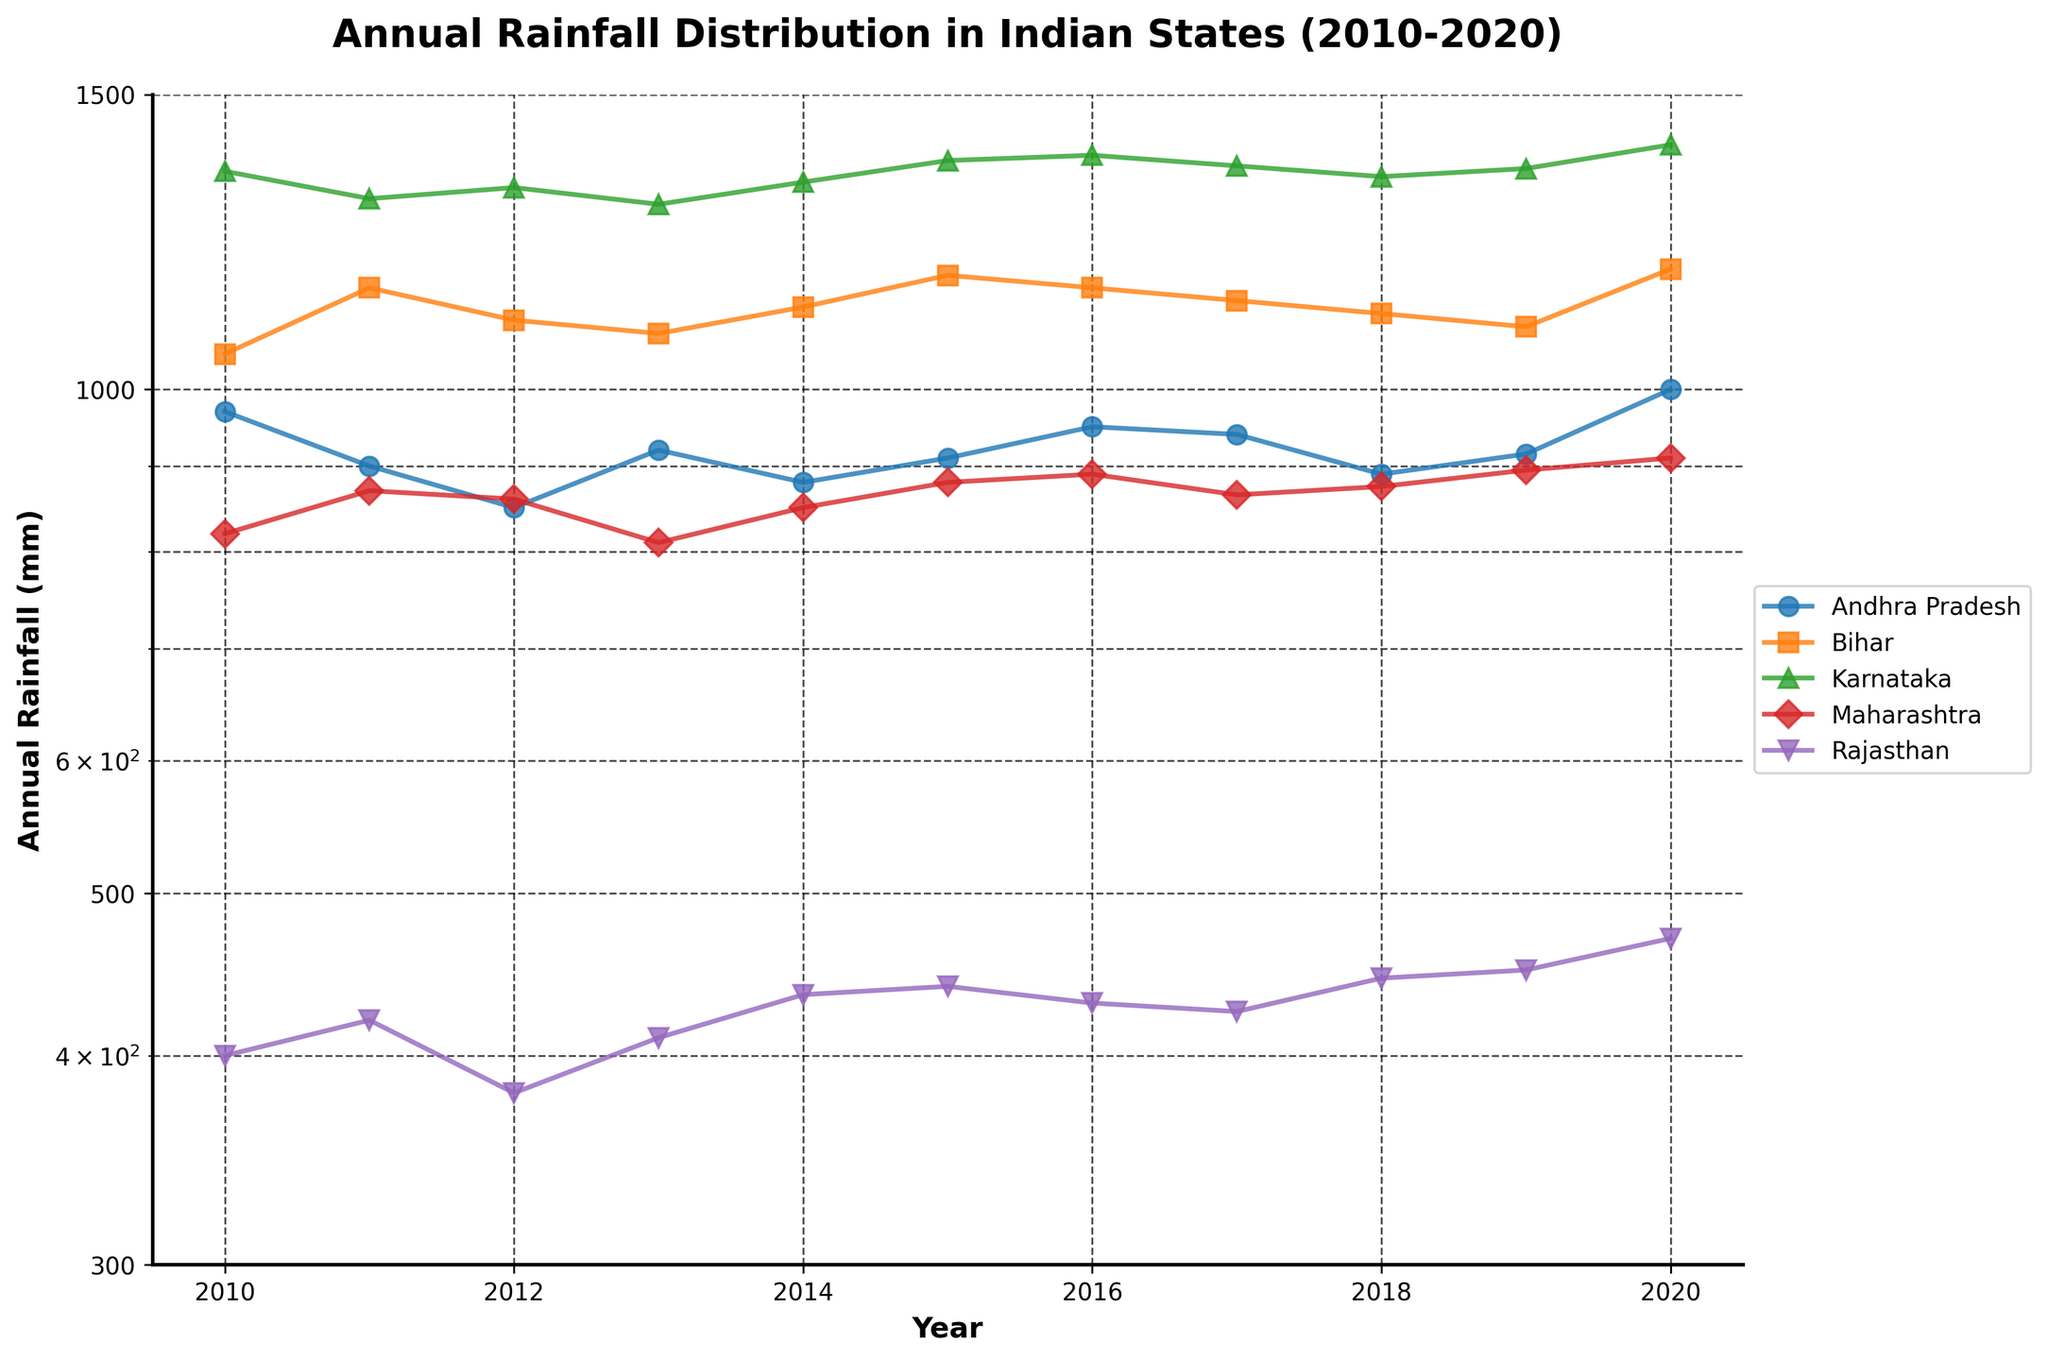What is the title of the plot? The title of the plot is usually displayed at the top of the figure. In this case, it is clearly stated as "Annual Rainfall Distribution in Indian States (2010-2020)".
Answer: Annual Rainfall Distribution in Indian States (2010-2020) Which state has the highest annual rainfall in 2020? By examining the endpoint of lines for the year 2020, Karnataka is at the highest point with the highest rainfall on the log scale.
Answer: Karnataka What is the range of the y-axis? The range of the y-axis can be deduced from observing the minimum and maximum labels. Here, the y-axis ranges from 300 to 1500 mm.
Answer: 300 to 1500 mm Which state shows the most consistent rainfall pattern over the years? Observing the lines' stability over the years, Bihar shows a steady and relatively consistent pattern without significant spikes or drops in rainfall.
Answer: Bihar What is the difference in annual rainfall between Karnataka and Rajasthan in 2010? By locating the points for both states in 2010 on the plot and checking their y-values, Karnataka has 1350 mm and Rajasthan has 400 mm. The difference is 1350 - 400.
Answer: 950 mm How does the rainfall trend of Maharashtra change from 2010 to 2020? The general trend for Maharashtra, as seen by the line, indicates an initial rise, a slight decline, and then a steady increase towards 2020. The trend is therefore slightly fluctuating but eventually upward.
Answer: Upward with fluctuations Which state experienced the sharpest increase in annual rainfall between any two consecutive years? By examining the steepest segments between consecutive years within lines, Bihar from 2019 to 2020 shows a significant rise, varying from 1090 mm to 1180 mm, indicating a sharpest increase.
Answer: Bihar (2019-2020) What is the average annual rainfall for Andhra Pradesh over the decade? Sum the annual rainfall values for Andhra Pradesh from 2010 to 2020 and divide by the number of years (11). Sum: 970 + 900 + 850 + 920 + 880 + 910 + 950 + 940 + 890 + 915 + 1000 = 11025. Average: 11025 / 11.
Answer: 1002.27 mm Which state shows an overall declining trend in annual rainfall from 2010 to 2020? By checking the general direction of lines from left to right, if any state line goes downward over the decade, Andhra Pradesh shows such a pattern with an overall declining trend despite minor fluctuations.
Answer: Andhra Pradesh What is the median rainfall value for Karnataka in the given period? List the rainfall values for Karnataka: [1350, 1300, 1320, 1290, 1330, 1370, 1380, 1360, 1340, 1355, 1400] and arrange them in order: [1290, 1300, 1320, 1330, 1340, 1350, 1355, 1360, 1370, 1380, 1400]. The median is the middle value, which is 1355.
Answer: 1355 mm 